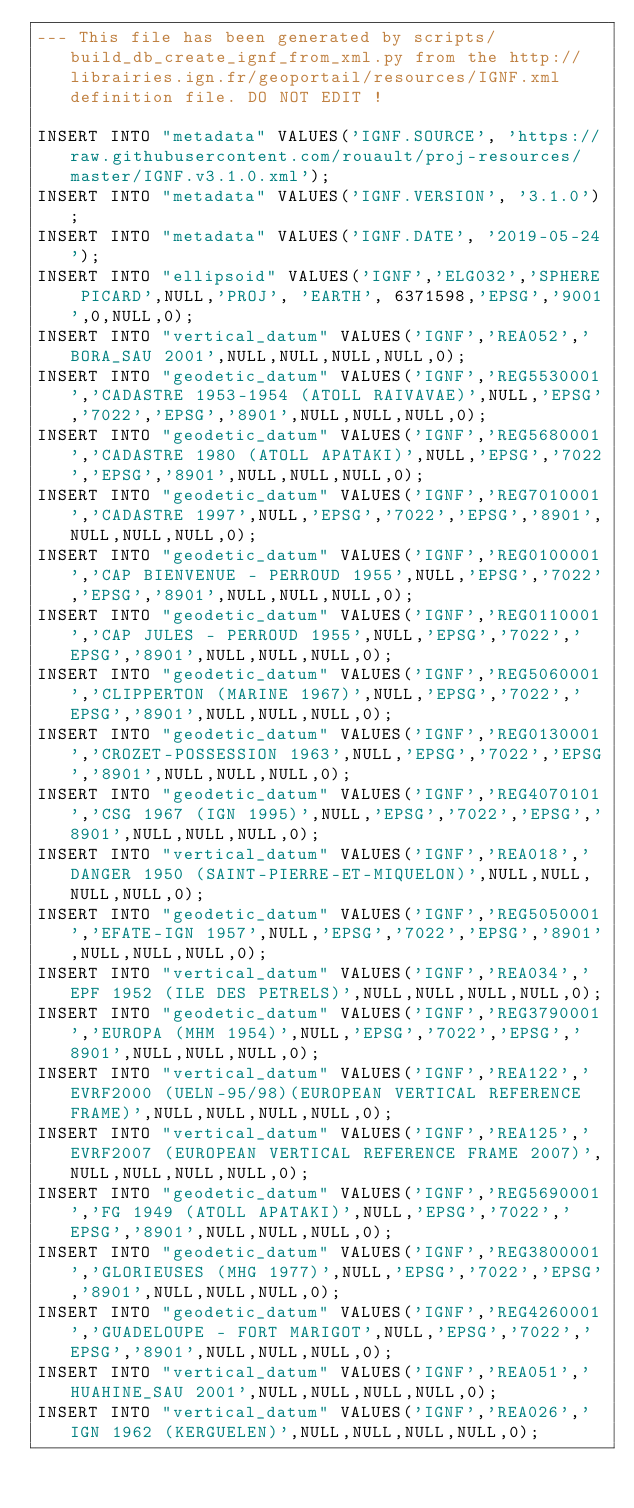Convert code to text. <code><loc_0><loc_0><loc_500><loc_500><_SQL_>--- This file has been generated by scripts/build_db_create_ignf_from_xml.py from the http://librairies.ign.fr/geoportail/resources/IGNF.xml definition file. DO NOT EDIT !

INSERT INTO "metadata" VALUES('IGNF.SOURCE', 'https://raw.githubusercontent.com/rouault/proj-resources/master/IGNF.v3.1.0.xml');
INSERT INTO "metadata" VALUES('IGNF.VERSION', '3.1.0');
INSERT INTO "metadata" VALUES('IGNF.DATE', '2019-05-24');
INSERT INTO "ellipsoid" VALUES('IGNF','ELG032','SPHERE PICARD',NULL,'PROJ', 'EARTH', 6371598,'EPSG','9001',0,NULL,0);
INSERT INTO "vertical_datum" VALUES('IGNF','REA052','BORA_SAU 2001',NULL,NULL,NULL,NULL,0);
INSERT INTO "geodetic_datum" VALUES('IGNF','REG5530001','CADASTRE 1953-1954 (ATOLL RAIVAVAE)',NULL,'EPSG','7022','EPSG','8901',NULL,NULL,NULL,0);
INSERT INTO "geodetic_datum" VALUES('IGNF','REG5680001','CADASTRE 1980 (ATOLL APATAKI)',NULL,'EPSG','7022','EPSG','8901',NULL,NULL,NULL,0);
INSERT INTO "geodetic_datum" VALUES('IGNF','REG7010001','CADASTRE 1997',NULL,'EPSG','7022','EPSG','8901',NULL,NULL,NULL,0);
INSERT INTO "geodetic_datum" VALUES('IGNF','REG0100001','CAP BIENVENUE - PERROUD 1955',NULL,'EPSG','7022','EPSG','8901',NULL,NULL,NULL,0);
INSERT INTO "geodetic_datum" VALUES('IGNF','REG0110001','CAP JULES - PERROUD 1955',NULL,'EPSG','7022','EPSG','8901',NULL,NULL,NULL,0);
INSERT INTO "geodetic_datum" VALUES('IGNF','REG5060001','CLIPPERTON (MARINE 1967)',NULL,'EPSG','7022','EPSG','8901',NULL,NULL,NULL,0);
INSERT INTO "geodetic_datum" VALUES('IGNF','REG0130001','CROZET-POSSESSION 1963',NULL,'EPSG','7022','EPSG','8901',NULL,NULL,NULL,0);
INSERT INTO "geodetic_datum" VALUES('IGNF','REG4070101','CSG 1967 (IGN 1995)',NULL,'EPSG','7022','EPSG','8901',NULL,NULL,NULL,0);
INSERT INTO "vertical_datum" VALUES('IGNF','REA018','DANGER 1950 (SAINT-PIERRE-ET-MIQUELON)',NULL,NULL,NULL,NULL,0);
INSERT INTO "geodetic_datum" VALUES('IGNF','REG5050001','EFATE-IGN 1957',NULL,'EPSG','7022','EPSG','8901',NULL,NULL,NULL,0);
INSERT INTO "vertical_datum" VALUES('IGNF','REA034','EPF 1952 (ILE DES PETRELS)',NULL,NULL,NULL,NULL,0);
INSERT INTO "geodetic_datum" VALUES('IGNF','REG3790001','EUROPA (MHM 1954)',NULL,'EPSG','7022','EPSG','8901',NULL,NULL,NULL,0);
INSERT INTO "vertical_datum" VALUES('IGNF','REA122','EVRF2000 (UELN-95/98)(EUROPEAN VERTICAL REFERENCE FRAME)',NULL,NULL,NULL,NULL,0);
INSERT INTO "vertical_datum" VALUES('IGNF','REA125','EVRF2007 (EUROPEAN VERTICAL REFERENCE FRAME 2007)',NULL,NULL,NULL,NULL,0);
INSERT INTO "geodetic_datum" VALUES('IGNF','REG5690001','FG 1949 (ATOLL APATAKI)',NULL,'EPSG','7022','EPSG','8901',NULL,NULL,NULL,0);
INSERT INTO "geodetic_datum" VALUES('IGNF','REG3800001','GLORIEUSES (MHG 1977)',NULL,'EPSG','7022','EPSG','8901',NULL,NULL,NULL,0);
INSERT INTO "geodetic_datum" VALUES('IGNF','REG4260001','GUADELOUPE - FORT MARIGOT',NULL,'EPSG','7022','EPSG','8901',NULL,NULL,NULL,0);
INSERT INTO "vertical_datum" VALUES('IGNF','REA051','HUAHINE_SAU 2001',NULL,NULL,NULL,NULL,0);
INSERT INTO "vertical_datum" VALUES('IGNF','REA026','IGN 1962 (KERGUELEN)',NULL,NULL,NULL,NULL,0);</code> 